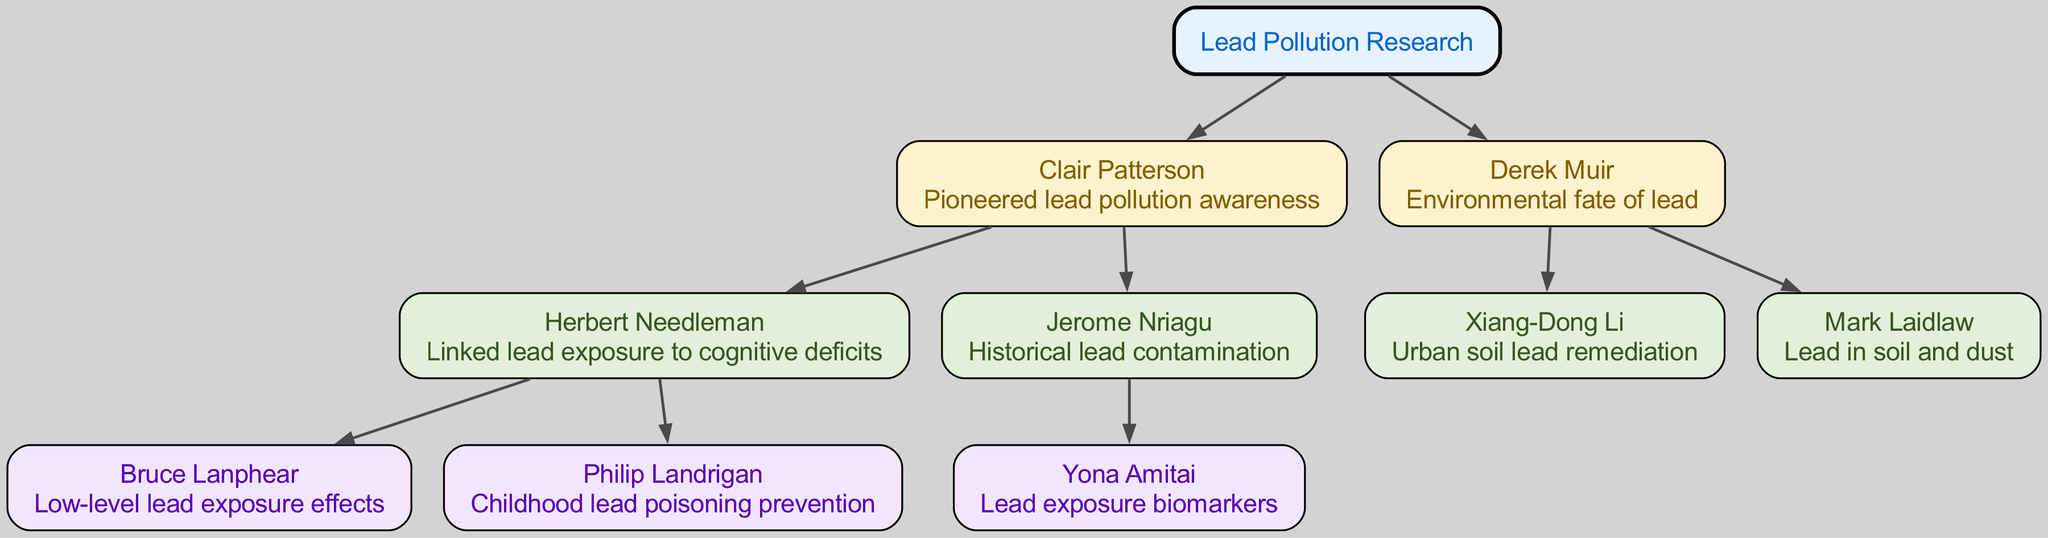What is the root of the family tree? The root node labeled "Lead Pollution Research" is the starting point of the diagram. It serves as the central theme for all the contributions listed in the tree.
Answer: Lead Pollution Research Who is the child of Clair Patterson that linked lead exposure to cognitive deficits? The only child under Clair Patterson that directly corresponds to the description of linking lead exposure to cognitive deficits is Herbert Needleman.
Answer: Herbert Needleman Which scientist contributed to childhood lead poisoning prevention? The scientist that has a direct connection to the prevention of childhood lead poisoning is Philip Landrigan, who is a descendant of Herbert Needleman.
Answer: Philip Landrigan How many children does Derek Muir have in this family tree? Looking at Derek Muir's entry in the tree, we can see that he has two children listed: Xiang-Dong Li and Mark Laidlaw. Thus, the count is two.
Answer: 2 What is the contribution of Bruce Lanphear? Bruce Lanphear is mentioned as focusing on the effects of low-level lead exposure, which is a specific area of lead pollution research.
Answer: Low-level lead exposure effects Who is the descendant of Jerome Nriagu? The only descendant listed under Jerome Nriagu is Yona Amitai, who is mentioned for research on lead exposure biomarkers.
Answer: Yona Amitai Which scientist's contributions are connected to urban soil lead remediation? The child of Derek Muir who corresponds to the topic of urban soil lead remediation is Xiang-Dong Li. His research relates specifically to this area.
Answer: Xiang-Dong Li What is the total number of notable scientists listed in this family tree? The family tree branches out into a total of eight notable scientists, counting all generations and children connected to the root.
Answer: 8 Which generation does Herbert Needleman belong to? Herbert Needleman is connected directly as a child of Clair Patterson, making him part of the first generation beyond the root node.
Answer: First generation 